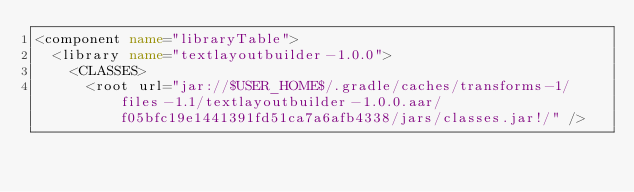<code> <loc_0><loc_0><loc_500><loc_500><_XML_><component name="libraryTable">
  <library name="textlayoutbuilder-1.0.0">
    <CLASSES>
      <root url="jar://$USER_HOME$/.gradle/caches/transforms-1/files-1.1/textlayoutbuilder-1.0.0.aar/f05bfc19e1441391fd51ca7a6afb4338/jars/classes.jar!/" /></code> 